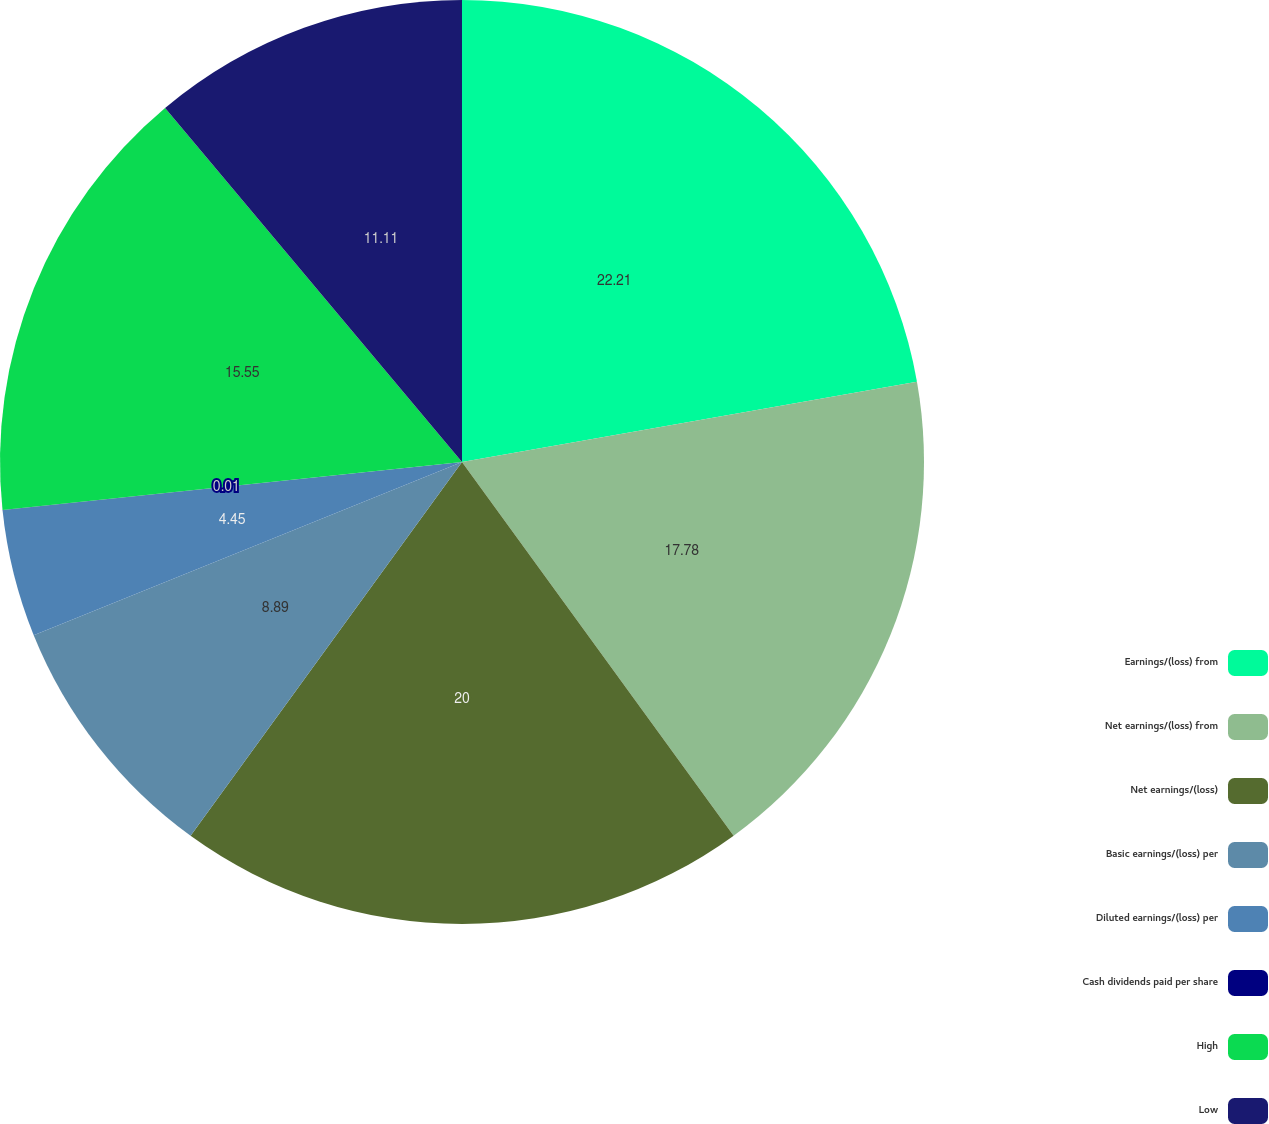Convert chart to OTSL. <chart><loc_0><loc_0><loc_500><loc_500><pie_chart><fcel>Earnings/(loss) from<fcel>Net earnings/(loss) from<fcel>Net earnings/(loss)<fcel>Basic earnings/(loss) per<fcel>Diluted earnings/(loss) per<fcel>Cash dividends paid per share<fcel>High<fcel>Low<nl><fcel>22.22%<fcel>17.78%<fcel>20.0%<fcel>8.89%<fcel>4.45%<fcel>0.01%<fcel>15.55%<fcel>11.11%<nl></chart> 